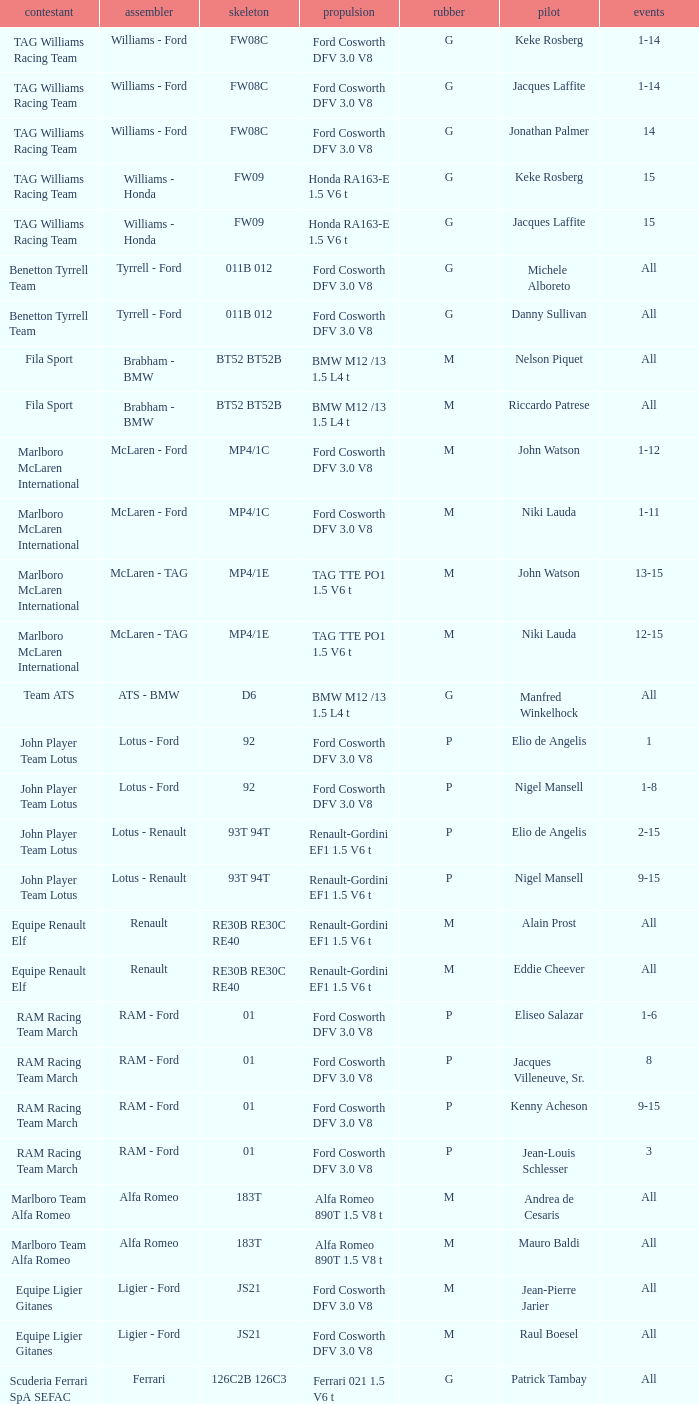Who is the constructor for driver Niki Lauda and a chassis of mp4/1c? McLaren - Ford. 